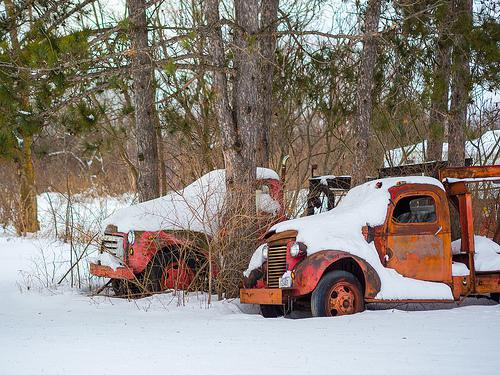Question: where was this photo taken?
Choices:
A. At the zoo.
B. A farm.
C. In a field.
D. A park.
Answer with the letter. Answer: C Question: who is driving the trucks?
Choices:
A. The delivery man.
B. Nobody.
C. The workers.
D. The carpool ladies.
Answer with the letter. Answer: B Question: how many trucks are there?
Choices:
A. 2.
B. 3.
C. 4.
D. 5.
Answer with the letter. Answer: A Question: what color is the snow?
Choices:
A. Gray.
B. Yellow.
C. White.
D. Silver.
Answer with the letter. Answer: C Question: when was this photo taken?
Choices:
A. Evening.
B. Daytime.
C. Morning.
D. Afternoon.
Answer with the letter. Answer: B 